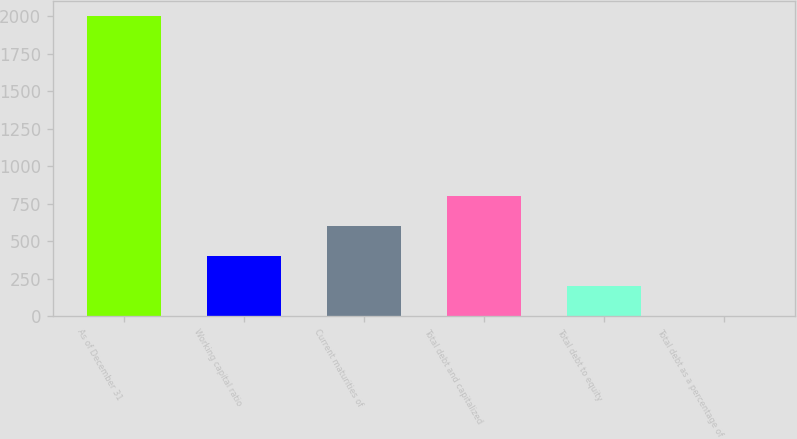Convert chart. <chart><loc_0><loc_0><loc_500><loc_500><bar_chart><fcel>As of December 31<fcel>Working capital ratio<fcel>Current maturities of<fcel>Total debt and capitalized<fcel>Total debt to equity<fcel>Total debt as a percentage of<nl><fcel>2001<fcel>400.56<fcel>600.61<fcel>800.66<fcel>200.51<fcel>0.46<nl></chart> 